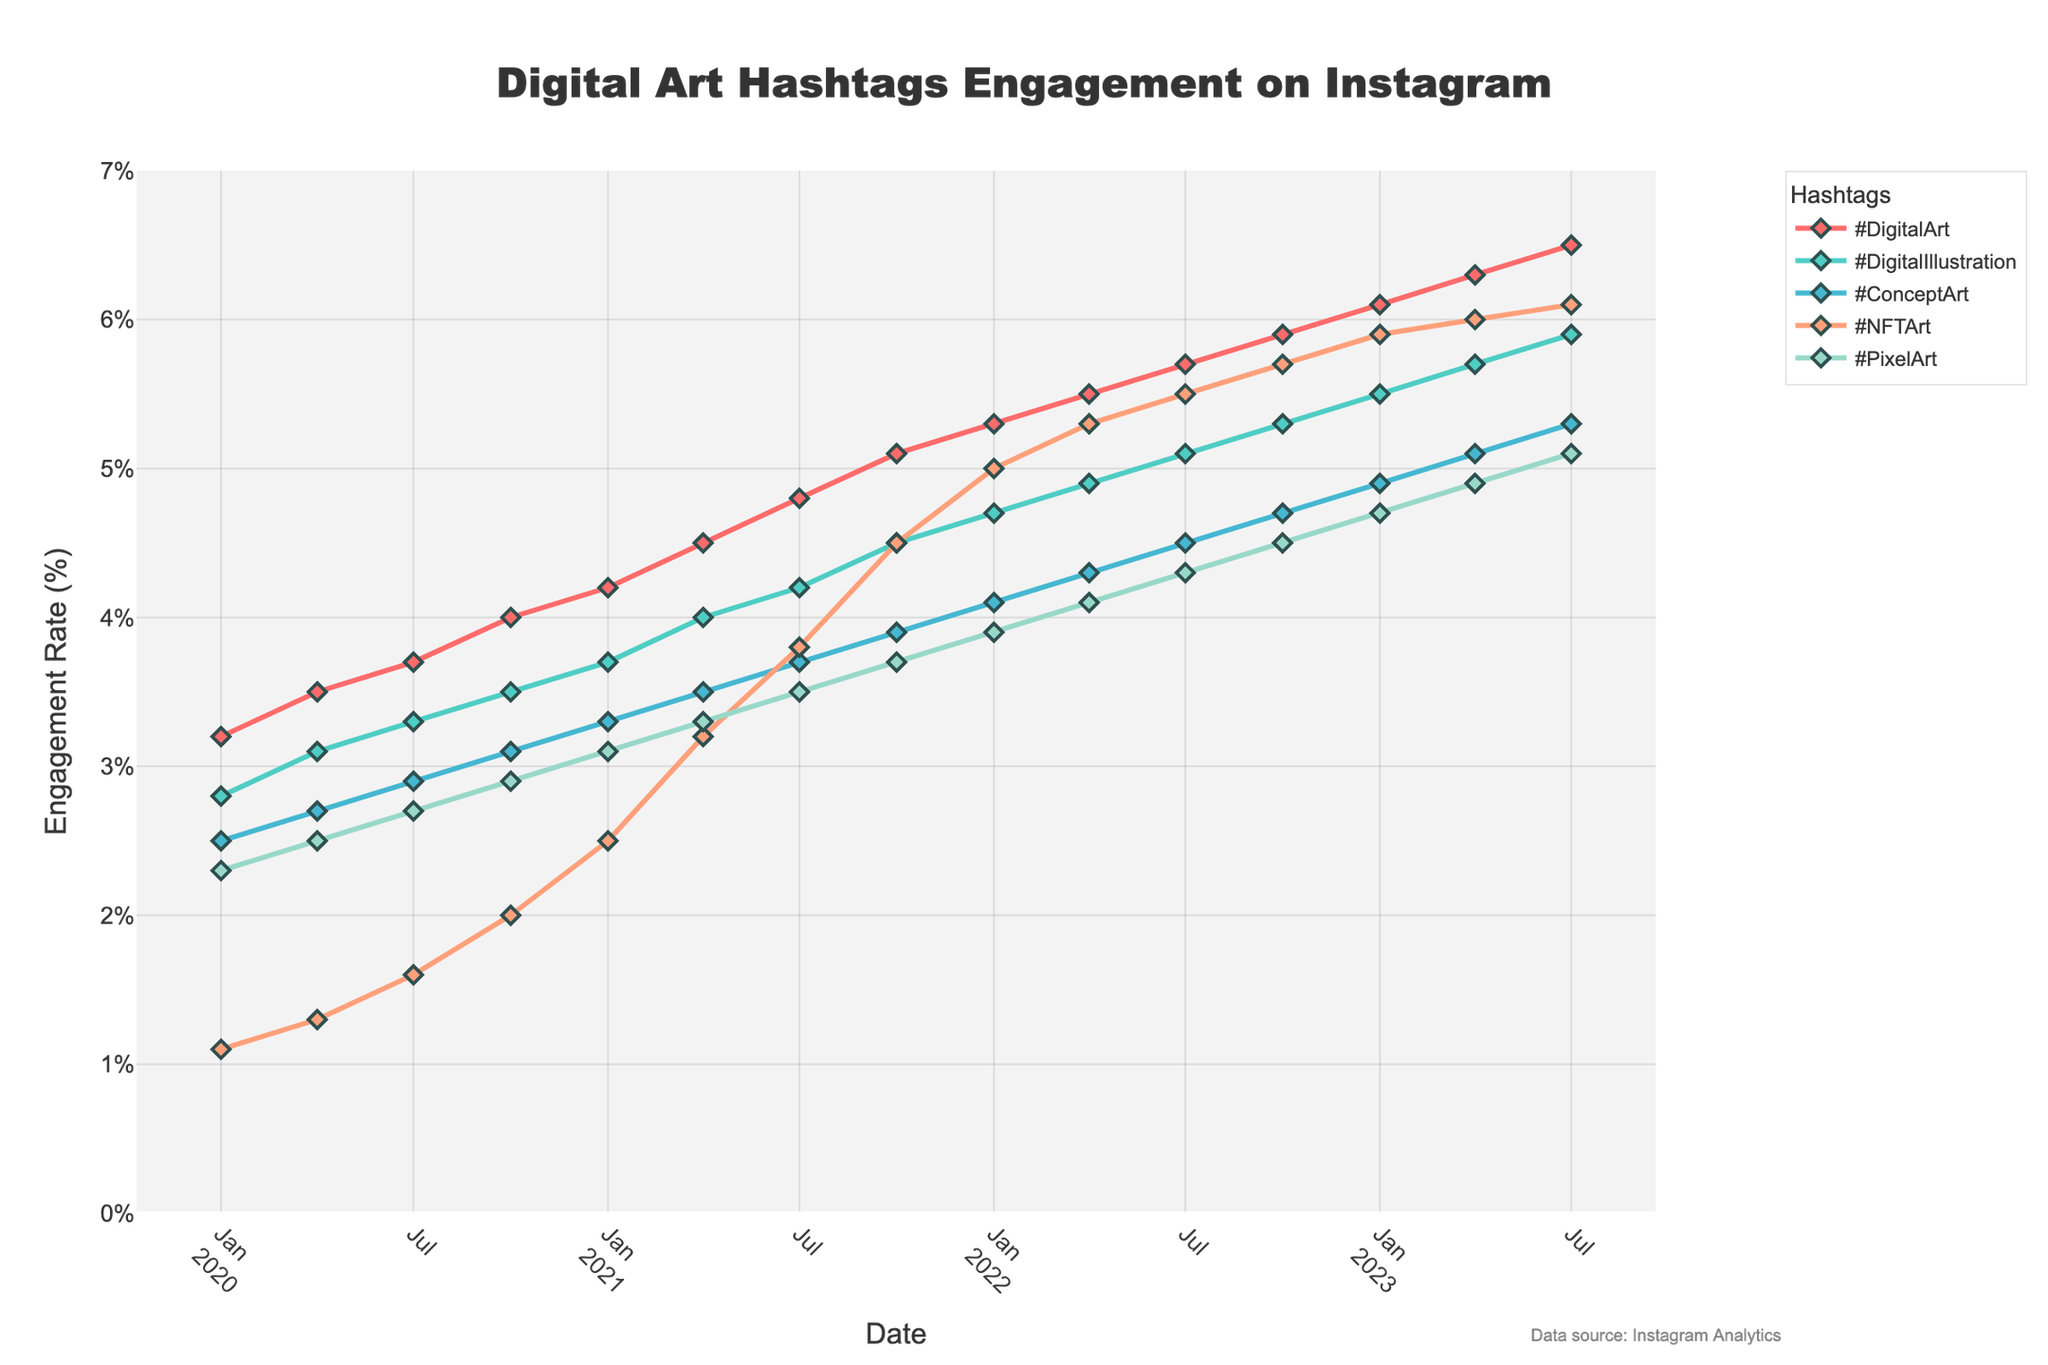What is the engagement rate trend for #DigitalArt from January 2020 to July 2023? From January 2020 to July 2023, the engagement rate for #DigitalArt increased consistently, starting at 3.2% in January 2020 and reaching 6.5% by July 2023. To determine the trend, observe the rising line for #DigitalArt between the respective dates.
Answer: Increasing Which hashtag had the highest engagement rate in April 2023? In April 2023, #NFTArt has the highest engagement rate among all the hashtags. This can be confirmed by comparing the heights of the lines at April 2023 on the x-axis, where #NFTArt reaches 6.0%.
Answer: #NFTArt Compare the engagement rates of #DigitalIllustration and #PixelArt in October 2022. Which one is higher and by how much? To compare the engagement rates for October 2022, locate both values from the graph. #DigitalIllustration has an engagement rate of 5.3%, while #PixelArt has a rate of 4.5%. Subtracting the two values gives 5.3% - 4.5% = 0.8%.
Answer: #DigitalIllustration by 0.8% How did the engagement rate of #ConceptArt change from April 2020 to April 2022? Observe the engagement rate for #ConceptArt at both points: April 2020 has an engagement rate of 2.7%, and April 2022 has 4.3%. The rate increased by 4.3% - 2.7% = 1.6%.
Answer: Increased by 1.6% Compare the engagement rates of #NFTArt and #DigitalArt in January 2021. Which one was higher, and what is the difference? In January 2021, #DigitalArt had an engagement rate of 4.2%, while #NFTArt was at 2.5%. Calculating the difference gives us 4.2% - 2.5% = 1.7%, with #DigitalArt being higher.
Answer: #DigitalArt by 1.7% What was the average engagement rate of #PixelArt from January 2022 to July 2023? To find the average over the specified period, sum the engagement rates for #PixelArt for January 2022 (3.9%), April 2022 (4.1%), July 2022 (4.3%), October 2022 (4.5%), January 2023 (4.7%), April 2023 (4.9%), and July 2023 (5.1%). The sum is 3.9 + 4.1 + 4.3 + 4.5 + 4.7 + 4.9 + 5.1 = 31.5. The average is 31.5/7 ≈ 4.5%.
Answer: 4.5% Which hashtag exhibited the most consistent growth over the three years? By observing the trends of the lines for each hashtag from January 2020 to July 2023, #DigitalArt shows the most consistent upward trend without any noticeable drops, indicating steady growth.
Answer: #DigitalArt In which month and year did #NFTArt surpass an engagement rate of 5% for the first time? Find the point on the graph where the line for #NFTArt first crosses the 5% mark. This happens in January 2022.
Answer: January 2022 